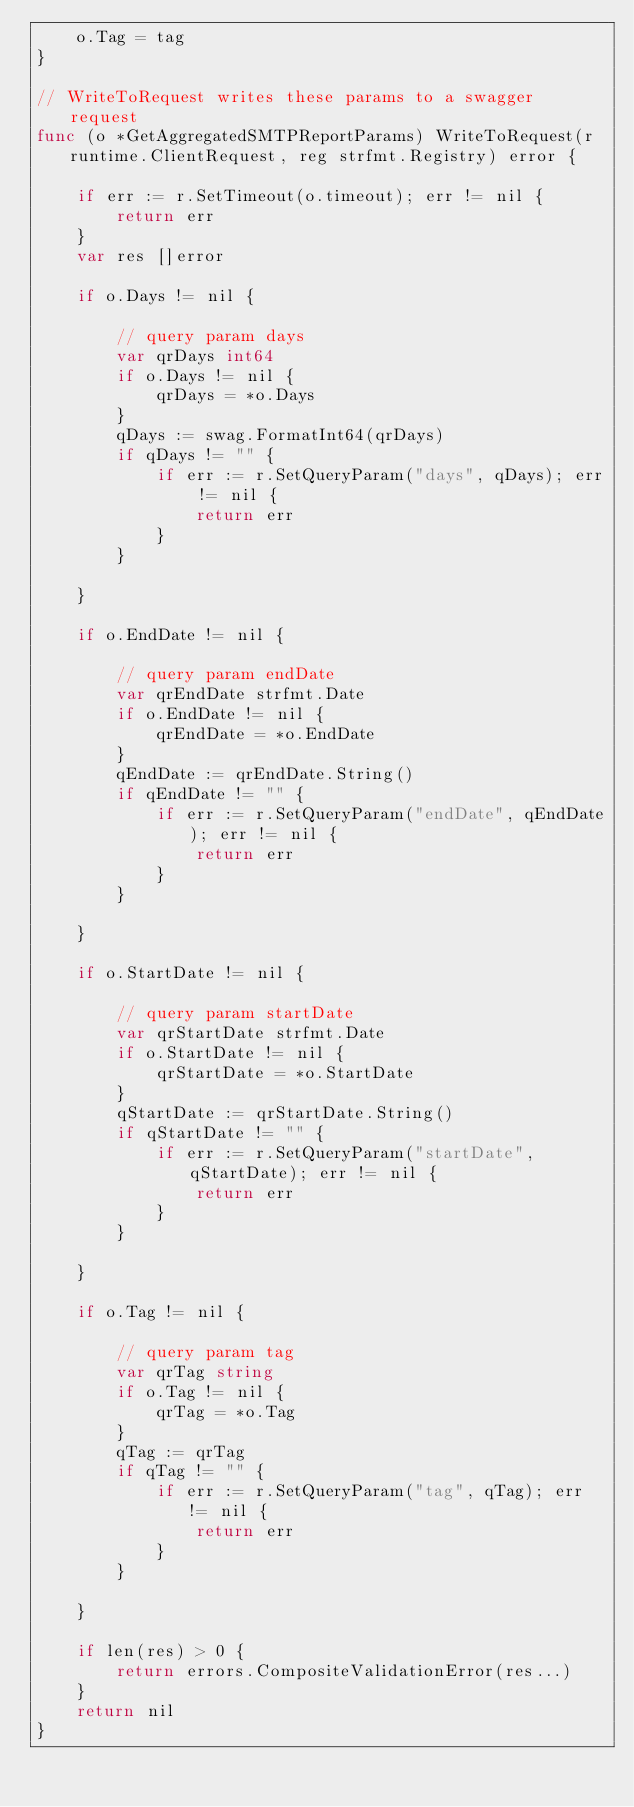Convert code to text. <code><loc_0><loc_0><loc_500><loc_500><_Go_>	o.Tag = tag
}

// WriteToRequest writes these params to a swagger request
func (o *GetAggregatedSMTPReportParams) WriteToRequest(r runtime.ClientRequest, reg strfmt.Registry) error {

	if err := r.SetTimeout(o.timeout); err != nil {
		return err
	}
	var res []error

	if o.Days != nil {

		// query param days
		var qrDays int64
		if o.Days != nil {
			qrDays = *o.Days
		}
		qDays := swag.FormatInt64(qrDays)
		if qDays != "" {
			if err := r.SetQueryParam("days", qDays); err != nil {
				return err
			}
		}

	}

	if o.EndDate != nil {

		// query param endDate
		var qrEndDate strfmt.Date
		if o.EndDate != nil {
			qrEndDate = *o.EndDate
		}
		qEndDate := qrEndDate.String()
		if qEndDate != "" {
			if err := r.SetQueryParam("endDate", qEndDate); err != nil {
				return err
			}
		}

	}

	if o.StartDate != nil {

		// query param startDate
		var qrStartDate strfmt.Date
		if o.StartDate != nil {
			qrStartDate = *o.StartDate
		}
		qStartDate := qrStartDate.String()
		if qStartDate != "" {
			if err := r.SetQueryParam("startDate", qStartDate); err != nil {
				return err
			}
		}

	}

	if o.Tag != nil {

		// query param tag
		var qrTag string
		if o.Tag != nil {
			qrTag = *o.Tag
		}
		qTag := qrTag
		if qTag != "" {
			if err := r.SetQueryParam("tag", qTag); err != nil {
				return err
			}
		}

	}

	if len(res) > 0 {
		return errors.CompositeValidationError(res...)
	}
	return nil
}
</code> 